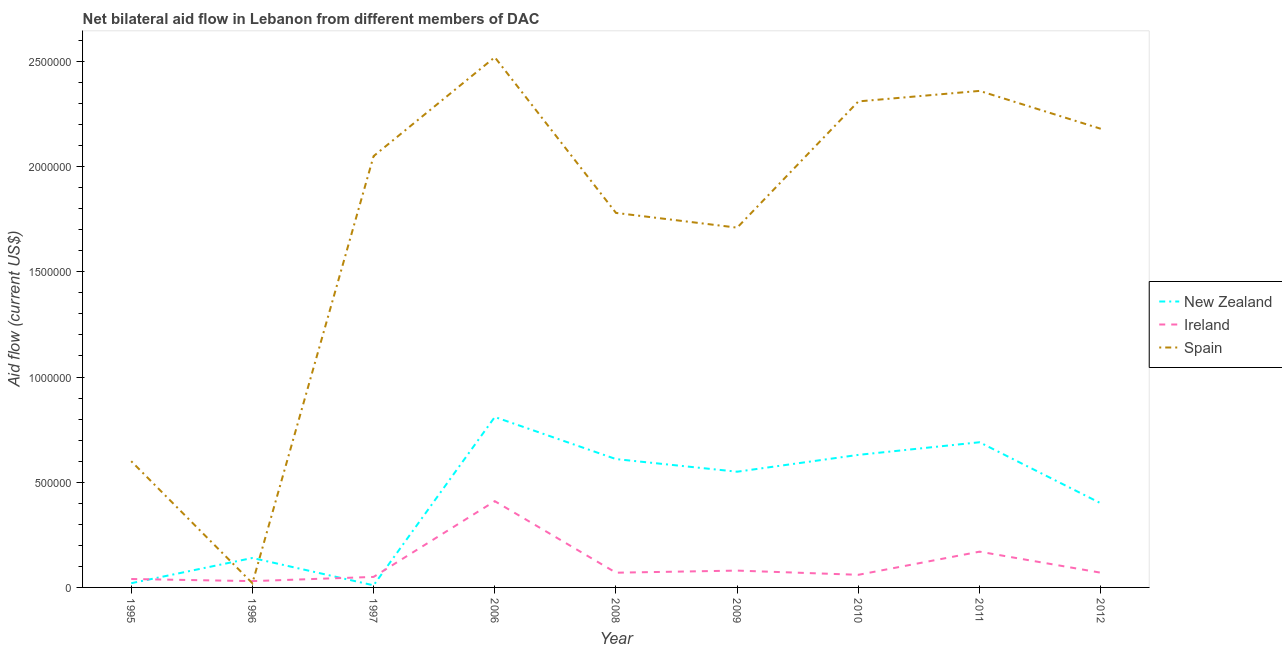Is the number of lines equal to the number of legend labels?
Give a very brief answer. Yes. What is the amount of aid provided by ireland in 2012?
Ensure brevity in your answer.  7.00e+04. Across all years, what is the maximum amount of aid provided by new zealand?
Give a very brief answer. 8.10e+05. Across all years, what is the minimum amount of aid provided by ireland?
Ensure brevity in your answer.  3.00e+04. In which year was the amount of aid provided by ireland maximum?
Ensure brevity in your answer.  2006. What is the total amount of aid provided by new zealand in the graph?
Provide a succinct answer. 3.86e+06. What is the difference between the amount of aid provided by new zealand in 1996 and that in 2010?
Provide a short and direct response. -4.90e+05. What is the difference between the amount of aid provided by ireland in 2006 and the amount of aid provided by spain in 1996?
Give a very brief answer. 3.90e+05. What is the average amount of aid provided by spain per year?
Offer a terse response. 1.73e+06. In the year 1996, what is the difference between the amount of aid provided by new zealand and amount of aid provided by spain?
Your response must be concise. 1.20e+05. What is the ratio of the amount of aid provided by ireland in 1997 to that in 2010?
Offer a very short reply. 0.83. What is the difference between the highest and the second highest amount of aid provided by ireland?
Provide a short and direct response. 2.40e+05. What is the difference between the highest and the lowest amount of aid provided by ireland?
Provide a succinct answer. 3.80e+05. In how many years, is the amount of aid provided by spain greater than the average amount of aid provided by spain taken over all years?
Provide a succinct answer. 6. Is the sum of the amount of aid provided by ireland in 1997 and 2009 greater than the maximum amount of aid provided by new zealand across all years?
Your answer should be very brief. No. Is it the case that in every year, the sum of the amount of aid provided by new zealand and amount of aid provided by ireland is greater than the amount of aid provided by spain?
Give a very brief answer. No. Is the amount of aid provided by spain strictly less than the amount of aid provided by new zealand over the years?
Offer a terse response. No. How many lines are there?
Make the answer very short. 3. What is the difference between two consecutive major ticks on the Y-axis?
Your answer should be compact. 5.00e+05. Does the graph contain any zero values?
Ensure brevity in your answer.  No. Does the graph contain grids?
Offer a very short reply. No. How many legend labels are there?
Give a very brief answer. 3. How are the legend labels stacked?
Provide a succinct answer. Vertical. What is the title of the graph?
Provide a succinct answer. Net bilateral aid flow in Lebanon from different members of DAC. Does "Unpaid family workers" appear as one of the legend labels in the graph?
Provide a succinct answer. No. What is the label or title of the X-axis?
Your answer should be very brief. Year. What is the Aid flow (current US$) of New Zealand in 1995?
Provide a short and direct response. 2.00e+04. What is the Aid flow (current US$) in Ireland in 1995?
Offer a terse response. 4.00e+04. What is the Aid flow (current US$) in New Zealand in 1996?
Provide a succinct answer. 1.40e+05. What is the Aid flow (current US$) of Spain in 1996?
Give a very brief answer. 2.00e+04. What is the Aid flow (current US$) in Ireland in 1997?
Keep it short and to the point. 5.00e+04. What is the Aid flow (current US$) of Spain in 1997?
Offer a very short reply. 2.05e+06. What is the Aid flow (current US$) in New Zealand in 2006?
Offer a very short reply. 8.10e+05. What is the Aid flow (current US$) in Spain in 2006?
Provide a succinct answer. 2.52e+06. What is the Aid flow (current US$) in New Zealand in 2008?
Offer a very short reply. 6.10e+05. What is the Aid flow (current US$) of Spain in 2008?
Make the answer very short. 1.78e+06. What is the Aid flow (current US$) in New Zealand in 2009?
Ensure brevity in your answer.  5.50e+05. What is the Aid flow (current US$) in Ireland in 2009?
Ensure brevity in your answer.  8.00e+04. What is the Aid flow (current US$) in Spain in 2009?
Your response must be concise. 1.71e+06. What is the Aid flow (current US$) in New Zealand in 2010?
Keep it short and to the point. 6.30e+05. What is the Aid flow (current US$) of Ireland in 2010?
Your answer should be compact. 6.00e+04. What is the Aid flow (current US$) of Spain in 2010?
Offer a very short reply. 2.31e+06. What is the Aid flow (current US$) of New Zealand in 2011?
Your answer should be very brief. 6.90e+05. What is the Aid flow (current US$) in Spain in 2011?
Ensure brevity in your answer.  2.36e+06. What is the Aid flow (current US$) in New Zealand in 2012?
Ensure brevity in your answer.  4.00e+05. What is the Aid flow (current US$) in Spain in 2012?
Your response must be concise. 2.18e+06. Across all years, what is the maximum Aid flow (current US$) in New Zealand?
Give a very brief answer. 8.10e+05. Across all years, what is the maximum Aid flow (current US$) in Spain?
Offer a terse response. 2.52e+06. Across all years, what is the minimum Aid flow (current US$) of Ireland?
Keep it short and to the point. 3.00e+04. Across all years, what is the minimum Aid flow (current US$) in Spain?
Provide a succinct answer. 2.00e+04. What is the total Aid flow (current US$) in New Zealand in the graph?
Your answer should be compact. 3.86e+06. What is the total Aid flow (current US$) in Ireland in the graph?
Offer a very short reply. 9.80e+05. What is the total Aid flow (current US$) in Spain in the graph?
Offer a very short reply. 1.55e+07. What is the difference between the Aid flow (current US$) in Ireland in 1995 and that in 1996?
Make the answer very short. 10000. What is the difference between the Aid flow (current US$) in Spain in 1995 and that in 1996?
Your answer should be compact. 5.80e+05. What is the difference between the Aid flow (current US$) of Spain in 1995 and that in 1997?
Your answer should be compact. -1.45e+06. What is the difference between the Aid flow (current US$) in New Zealand in 1995 and that in 2006?
Provide a succinct answer. -7.90e+05. What is the difference between the Aid flow (current US$) in Ireland in 1995 and that in 2006?
Give a very brief answer. -3.70e+05. What is the difference between the Aid flow (current US$) of Spain in 1995 and that in 2006?
Provide a short and direct response. -1.92e+06. What is the difference between the Aid flow (current US$) in New Zealand in 1995 and that in 2008?
Keep it short and to the point. -5.90e+05. What is the difference between the Aid flow (current US$) in Spain in 1995 and that in 2008?
Give a very brief answer. -1.18e+06. What is the difference between the Aid flow (current US$) in New Zealand in 1995 and that in 2009?
Offer a terse response. -5.30e+05. What is the difference between the Aid flow (current US$) in Spain in 1995 and that in 2009?
Your response must be concise. -1.11e+06. What is the difference between the Aid flow (current US$) in New Zealand in 1995 and that in 2010?
Offer a terse response. -6.10e+05. What is the difference between the Aid flow (current US$) in Spain in 1995 and that in 2010?
Provide a short and direct response. -1.71e+06. What is the difference between the Aid flow (current US$) of New Zealand in 1995 and that in 2011?
Your answer should be very brief. -6.70e+05. What is the difference between the Aid flow (current US$) in Spain in 1995 and that in 2011?
Keep it short and to the point. -1.76e+06. What is the difference between the Aid flow (current US$) in New Zealand in 1995 and that in 2012?
Make the answer very short. -3.80e+05. What is the difference between the Aid flow (current US$) in Spain in 1995 and that in 2012?
Offer a terse response. -1.58e+06. What is the difference between the Aid flow (current US$) in New Zealand in 1996 and that in 1997?
Your answer should be compact. 1.30e+05. What is the difference between the Aid flow (current US$) in Spain in 1996 and that in 1997?
Offer a terse response. -2.03e+06. What is the difference between the Aid flow (current US$) in New Zealand in 1996 and that in 2006?
Your answer should be compact. -6.70e+05. What is the difference between the Aid flow (current US$) of Ireland in 1996 and that in 2006?
Your answer should be compact. -3.80e+05. What is the difference between the Aid flow (current US$) of Spain in 1996 and that in 2006?
Your response must be concise. -2.50e+06. What is the difference between the Aid flow (current US$) in New Zealand in 1996 and that in 2008?
Ensure brevity in your answer.  -4.70e+05. What is the difference between the Aid flow (current US$) in Ireland in 1996 and that in 2008?
Provide a succinct answer. -4.00e+04. What is the difference between the Aid flow (current US$) in Spain in 1996 and that in 2008?
Offer a terse response. -1.76e+06. What is the difference between the Aid flow (current US$) in New Zealand in 1996 and that in 2009?
Your response must be concise. -4.10e+05. What is the difference between the Aid flow (current US$) in Ireland in 1996 and that in 2009?
Make the answer very short. -5.00e+04. What is the difference between the Aid flow (current US$) in Spain in 1996 and that in 2009?
Make the answer very short. -1.69e+06. What is the difference between the Aid flow (current US$) of New Zealand in 1996 and that in 2010?
Ensure brevity in your answer.  -4.90e+05. What is the difference between the Aid flow (current US$) of Spain in 1996 and that in 2010?
Provide a short and direct response. -2.29e+06. What is the difference between the Aid flow (current US$) in New Zealand in 1996 and that in 2011?
Your answer should be very brief. -5.50e+05. What is the difference between the Aid flow (current US$) in Spain in 1996 and that in 2011?
Provide a succinct answer. -2.34e+06. What is the difference between the Aid flow (current US$) of Ireland in 1996 and that in 2012?
Provide a succinct answer. -4.00e+04. What is the difference between the Aid flow (current US$) of Spain in 1996 and that in 2012?
Ensure brevity in your answer.  -2.16e+06. What is the difference between the Aid flow (current US$) of New Zealand in 1997 and that in 2006?
Your answer should be compact. -8.00e+05. What is the difference between the Aid flow (current US$) of Ireland in 1997 and that in 2006?
Give a very brief answer. -3.60e+05. What is the difference between the Aid flow (current US$) in Spain in 1997 and that in 2006?
Make the answer very short. -4.70e+05. What is the difference between the Aid flow (current US$) in New Zealand in 1997 and that in 2008?
Ensure brevity in your answer.  -6.00e+05. What is the difference between the Aid flow (current US$) of Spain in 1997 and that in 2008?
Make the answer very short. 2.70e+05. What is the difference between the Aid flow (current US$) of New Zealand in 1997 and that in 2009?
Ensure brevity in your answer.  -5.40e+05. What is the difference between the Aid flow (current US$) in New Zealand in 1997 and that in 2010?
Ensure brevity in your answer.  -6.20e+05. What is the difference between the Aid flow (current US$) in Ireland in 1997 and that in 2010?
Keep it short and to the point. -10000. What is the difference between the Aid flow (current US$) of Spain in 1997 and that in 2010?
Your response must be concise. -2.60e+05. What is the difference between the Aid flow (current US$) of New Zealand in 1997 and that in 2011?
Your response must be concise. -6.80e+05. What is the difference between the Aid flow (current US$) in Ireland in 1997 and that in 2011?
Provide a succinct answer. -1.20e+05. What is the difference between the Aid flow (current US$) of Spain in 1997 and that in 2011?
Ensure brevity in your answer.  -3.10e+05. What is the difference between the Aid flow (current US$) of New Zealand in 1997 and that in 2012?
Your answer should be compact. -3.90e+05. What is the difference between the Aid flow (current US$) in Ireland in 1997 and that in 2012?
Ensure brevity in your answer.  -2.00e+04. What is the difference between the Aid flow (current US$) of Spain in 1997 and that in 2012?
Offer a terse response. -1.30e+05. What is the difference between the Aid flow (current US$) of Spain in 2006 and that in 2008?
Offer a terse response. 7.40e+05. What is the difference between the Aid flow (current US$) in Spain in 2006 and that in 2009?
Make the answer very short. 8.10e+05. What is the difference between the Aid flow (current US$) in Spain in 2006 and that in 2010?
Offer a terse response. 2.10e+05. What is the difference between the Aid flow (current US$) in Ireland in 2006 and that in 2011?
Offer a very short reply. 2.40e+05. What is the difference between the Aid flow (current US$) of Spain in 2006 and that in 2011?
Offer a terse response. 1.60e+05. What is the difference between the Aid flow (current US$) in New Zealand in 2006 and that in 2012?
Make the answer very short. 4.10e+05. What is the difference between the Aid flow (current US$) of New Zealand in 2008 and that in 2009?
Make the answer very short. 6.00e+04. What is the difference between the Aid flow (current US$) of Ireland in 2008 and that in 2009?
Your answer should be very brief. -10000. What is the difference between the Aid flow (current US$) in Spain in 2008 and that in 2009?
Give a very brief answer. 7.00e+04. What is the difference between the Aid flow (current US$) in New Zealand in 2008 and that in 2010?
Give a very brief answer. -2.00e+04. What is the difference between the Aid flow (current US$) in Ireland in 2008 and that in 2010?
Provide a succinct answer. 10000. What is the difference between the Aid flow (current US$) in Spain in 2008 and that in 2010?
Give a very brief answer. -5.30e+05. What is the difference between the Aid flow (current US$) in New Zealand in 2008 and that in 2011?
Your response must be concise. -8.00e+04. What is the difference between the Aid flow (current US$) of Ireland in 2008 and that in 2011?
Provide a short and direct response. -1.00e+05. What is the difference between the Aid flow (current US$) in Spain in 2008 and that in 2011?
Give a very brief answer. -5.80e+05. What is the difference between the Aid flow (current US$) of Spain in 2008 and that in 2012?
Your answer should be compact. -4.00e+05. What is the difference between the Aid flow (current US$) in Spain in 2009 and that in 2010?
Your response must be concise. -6.00e+05. What is the difference between the Aid flow (current US$) of Ireland in 2009 and that in 2011?
Your answer should be very brief. -9.00e+04. What is the difference between the Aid flow (current US$) of Spain in 2009 and that in 2011?
Provide a short and direct response. -6.50e+05. What is the difference between the Aid flow (current US$) of New Zealand in 2009 and that in 2012?
Offer a very short reply. 1.50e+05. What is the difference between the Aid flow (current US$) of Spain in 2009 and that in 2012?
Provide a short and direct response. -4.70e+05. What is the difference between the Aid flow (current US$) of New Zealand in 2010 and that in 2011?
Your response must be concise. -6.00e+04. What is the difference between the Aid flow (current US$) of Ireland in 2010 and that in 2011?
Offer a terse response. -1.10e+05. What is the difference between the Aid flow (current US$) of New Zealand in 2010 and that in 2012?
Ensure brevity in your answer.  2.30e+05. What is the difference between the Aid flow (current US$) in Ireland in 2010 and that in 2012?
Give a very brief answer. -10000. What is the difference between the Aid flow (current US$) of Spain in 2010 and that in 2012?
Offer a very short reply. 1.30e+05. What is the difference between the Aid flow (current US$) of New Zealand in 2011 and that in 2012?
Offer a very short reply. 2.90e+05. What is the difference between the Aid flow (current US$) in Spain in 2011 and that in 2012?
Provide a short and direct response. 1.80e+05. What is the difference between the Aid flow (current US$) of New Zealand in 1995 and the Aid flow (current US$) of Ireland in 1996?
Provide a succinct answer. -10000. What is the difference between the Aid flow (current US$) in New Zealand in 1995 and the Aid flow (current US$) in Spain in 1996?
Your response must be concise. 0. What is the difference between the Aid flow (current US$) in Ireland in 1995 and the Aid flow (current US$) in Spain in 1996?
Give a very brief answer. 2.00e+04. What is the difference between the Aid flow (current US$) in New Zealand in 1995 and the Aid flow (current US$) in Spain in 1997?
Ensure brevity in your answer.  -2.03e+06. What is the difference between the Aid flow (current US$) of Ireland in 1995 and the Aid flow (current US$) of Spain in 1997?
Your answer should be very brief. -2.01e+06. What is the difference between the Aid flow (current US$) of New Zealand in 1995 and the Aid flow (current US$) of Ireland in 2006?
Make the answer very short. -3.90e+05. What is the difference between the Aid flow (current US$) of New Zealand in 1995 and the Aid flow (current US$) of Spain in 2006?
Make the answer very short. -2.50e+06. What is the difference between the Aid flow (current US$) in Ireland in 1995 and the Aid flow (current US$) in Spain in 2006?
Keep it short and to the point. -2.48e+06. What is the difference between the Aid flow (current US$) in New Zealand in 1995 and the Aid flow (current US$) in Spain in 2008?
Your response must be concise. -1.76e+06. What is the difference between the Aid flow (current US$) in Ireland in 1995 and the Aid flow (current US$) in Spain in 2008?
Give a very brief answer. -1.74e+06. What is the difference between the Aid flow (current US$) of New Zealand in 1995 and the Aid flow (current US$) of Spain in 2009?
Offer a very short reply. -1.69e+06. What is the difference between the Aid flow (current US$) in Ireland in 1995 and the Aid flow (current US$) in Spain in 2009?
Provide a succinct answer. -1.67e+06. What is the difference between the Aid flow (current US$) of New Zealand in 1995 and the Aid flow (current US$) of Ireland in 2010?
Your answer should be very brief. -4.00e+04. What is the difference between the Aid flow (current US$) of New Zealand in 1995 and the Aid flow (current US$) of Spain in 2010?
Keep it short and to the point. -2.29e+06. What is the difference between the Aid flow (current US$) in Ireland in 1995 and the Aid flow (current US$) in Spain in 2010?
Keep it short and to the point. -2.27e+06. What is the difference between the Aid flow (current US$) of New Zealand in 1995 and the Aid flow (current US$) of Ireland in 2011?
Offer a very short reply. -1.50e+05. What is the difference between the Aid flow (current US$) in New Zealand in 1995 and the Aid flow (current US$) in Spain in 2011?
Give a very brief answer. -2.34e+06. What is the difference between the Aid flow (current US$) of Ireland in 1995 and the Aid flow (current US$) of Spain in 2011?
Give a very brief answer. -2.32e+06. What is the difference between the Aid flow (current US$) of New Zealand in 1995 and the Aid flow (current US$) of Spain in 2012?
Ensure brevity in your answer.  -2.16e+06. What is the difference between the Aid flow (current US$) in Ireland in 1995 and the Aid flow (current US$) in Spain in 2012?
Your answer should be compact. -2.14e+06. What is the difference between the Aid flow (current US$) of New Zealand in 1996 and the Aid flow (current US$) of Ireland in 1997?
Keep it short and to the point. 9.00e+04. What is the difference between the Aid flow (current US$) in New Zealand in 1996 and the Aid flow (current US$) in Spain in 1997?
Provide a succinct answer. -1.91e+06. What is the difference between the Aid flow (current US$) of Ireland in 1996 and the Aid flow (current US$) of Spain in 1997?
Your answer should be very brief. -2.02e+06. What is the difference between the Aid flow (current US$) in New Zealand in 1996 and the Aid flow (current US$) in Spain in 2006?
Your response must be concise. -2.38e+06. What is the difference between the Aid flow (current US$) in Ireland in 1996 and the Aid flow (current US$) in Spain in 2006?
Your answer should be very brief. -2.49e+06. What is the difference between the Aid flow (current US$) of New Zealand in 1996 and the Aid flow (current US$) of Ireland in 2008?
Give a very brief answer. 7.00e+04. What is the difference between the Aid flow (current US$) of New Zealand in 1996 and the Aid flow (current US$) of Spain in 2008?
Give a very brief answer. -1.64e+06. What is the difference between the Aid flow (current US$) in Ireland in 1996 and the Aid flow (current US$) in Spain in 2008?
Give a very brief answer. -1.75e+06. What is the difference between the Aid flow (current US$) in New Zealand in 1996 and the Aid flow (current US$) in Spain in 2009?
Make the answer very short. -1.57e+06. What is the difference between the Aid flow (current US$) of Ireland in 1996 and the Aid flow (current US$) of Spain in 2009?
Your answer should be very brief. -1.68e+06. What is the difference between the Aid flow (current US$) in New Zealand in 1996 and the Aid flow (current US$) in Ireland in 2010?
Offer a terse response. 8.00e+04. What is the difference between the Aid flow (current US$) in New Zealand in 1996 and the Aid flow (current US$) in Spain in 2010?
Give a very brief answer. -2.17e+06. What is the difference between the Aid flow (current US$) of Ireland in 1996 and the Aid flow (current US$) of Spain in 2010?
Your response must be concise. -2.28e+06. What is the difference between the Aid flow (current US$) of New Zealand in 1996 and the Aid flow (current US$) of Spain in 2011?
Your answer should be very brief. -2.22e+06. What is the difference between the Aid flow (current US$) in Ireland in 1996 and the Aid flow (current US$) in Spain in 2011?
Provide a short and direct response. -2.33e+06. What is the difference between the Aid flow (current US$) in New Zealand in 1996 and the Aid flow (current US$) in Ireland in 2012?
Your answer should be very brief. 7.00e+04. What is the difference between the Aid flow (current US$) in New Zealand in 1996 and the Aid flow (current US$) in Spain in 2012?
Offer a very short reply. -2.04e+06. What is the difference between the Aid flow (current US$) of Ireland in 1996 and the Aid flow (current US$) of Spain in 2012?
Give a very brief answer. -2.15e+06. What is the difference between the Aid flow (current US$) in New Zealand in 1997 and the Aid flow (current US$) in Ireland in 2006?
Provide a short and direct response. -4.00e+05. What is the difference between the Aid flow (current US$) of New Zealand in 1997 and the Aid flow (current US$) of Spain in 2006?
Ensure brevity in your answer.  -2.51e+06. What is the difference between the Aid flow (current US$) in Ireland in 1997 and the Aid flow (current US$) in Spain in 2006?
Your answer should be very brief. -2.47e+06. What is the difference between the Aid flow (current US$) in New Zealand in 1997 and the Aid flow (current US$) in Spain in 2008?
Your response must be concise. -1.77e+06. What is the difference between the Aid flow (current US$) in Ireland in 1997 and the Aid flow (current US$) in Spain in 2008?
Provide a short and direct response. -1.73e+06. What is the difference between the Aid flow (current US$) of New Zealand in 1997 and the Aid flow (current US$) of Spain in 2009?
Your response must be concise. -1.70e+06. What is the difference between the Aid flow (current US$) in Ireland in 1997 and the Aid flow (current US$) in Spain in 2009?
Offer a very short reply. -1.66e+06. What is the difference between the Aid flow (current US$) of New Zealand in 1997 and the Aid flow (current US$) of Spain in 2010?
Your response must be concise. -2.30e+06. What is the difference between the Aid flow (current US$) in Ireland in 1997 and the Aid flow (current US$) in Spain in 2010?
Your answer should be compact. -2.26e+06. What is the difference between the Aid flow (current US$) in New Zealand in 1997 and the Aid flow (current US$) in Spain in 2011?
Offer a very short reply. -2.35e+06. What is the difference between the Aid flow (current US$) in Ireland in 1997 and the Aid flow (current US$) in Spain in 2011?
Keep it short and to the point. -2.31e+06. What is the difference between the Aid flow (current US$) of New Zealand in 1997 and the Aid flow (current US$) of Ireland in 2012?
Give a very brief answer. -6.00e+04. What is the difference between the Aid flow (current US$) in New Zealand in 1997 and the Aid flow (current US$) in Spain in 2012?
Keep it short and to the point. -2.17e+06. What is the difference between the Aid flow (current US$) in Ireland in 1997 and the Aid flow (current US$) in Spain in 2012?
Your answer should be very brief. -2.13e+06. What is the difference between the Aid flow (current US$) of New Zealand in 2006 and the Aid flow (current US$) of Ireland in 2008?
Make the answer very short. 7.40e+05. What is the difference between the Aid flow (current US$) of New Zealand in 2006 and the Aid flow (current US$) of Spain in 2008?
Make the answer very short. -9.70e+05. What is the difference between the Aid flow (current US$) in Ireland in 2006 and the Aid flow (current US$) in Spain in 2008?
Give a very brief answer. -1.37e+06. What is the difference between the Aid flow (current US$) of New Zealand in 2006 and the Aid flow (current US$) of Ireland in 2009?
Keep it short and to the point. 7.30e+05. What is the difference between the Aid flow (current US$) of New Zealand in 2006 and the Aid flow (current US$) of Spain in 2009?
Offer a terse response. -9.00e+05. What is the difference between the Aid flow (current US$) of Ireland in 2006 and the Aid flow (current US$) of Spain in 2009?
Keep it short and to the point. -1.30e+06. What is the difference between the Aid flow (current US$) of New Zealand in 2006 and the Aid flow (current US$) of Ireland in 2010?
Give a very brief answer. 7.50e+05. What is the difference between the Aid flow (current US$) in New Zealand in 2006 and the Aid flow (current US$) in Spain in 2010?
Ensure brevity in your answer.  -1.50e+06. What is the difference between the Aid flow (current US$) of Ireland in 2006 and the Aid flow (current US$) of Spain in 2010?
Provide a succinct answer. -1.90e+06. What is the difference between the Aid flow (current US$) in New Zealand in 2006 and the Aid flow (current US$) in Ireland in 2011?
Your answer should be very brief. 6.40e+05. What is the difference between the Aid flow (current US$) in New Zealand in 2006 and the Aid flow (current US$) in Spain in 2011?
Your answer should be very brief. -1.55e+06. What is the difference between the Aid flow (current US$) in Ireland in 2006 and the Aid flow (current US$) in Spain in 2011?
Provide a short and direct response. -1.95e+06. What is the difference between the Aid flow (current US$) in New Zealand in 2006 and the Aid flow (current US$) in Ireland in 2012?
Make the answer very short. 7.40e+05. What is the difference between the Aid flow (current US$) of New Zealand in 2006 and the Aid flow (current US$) of Spain in 2012?
Offer a terse response. -1.37e+06. What is the difference between the Aid flow (current US$) in Ireland in 2006 and the Aid flow (current US$) in Spain in 2012?
Your answer should be compact. -1.77e+06. What is the difference between the Aid flow (current US$) in New Zealand in 2008 and the Aid flow (current US$) in Ireland in 2009?
Ensure brevity in your answer.  5.30e+05. What is the difference between the Aid flow (current US$) of New Zealand in 2008 and the Aid flow (current US$) of Spain in 2009?
Provide a short and direct response. -1.10e+06. What is the difference between the Aid flow (current US$) of Ireland in 2008 and the Aid flow (current US$) of Spain in 2009?
Your response must be concise. -1.64e+06. What is the difference between the Aid flow (current US$) of New Zealand in 2008 and the Aid flow (current US$) of Ireland in 2010?
Offer a very short reply. 5.50e+05. What is the difference between the Aid flow (current US$) in New Zealand in 2008 and the Aid flow (current US$) in Spain in 2010?
Your response must be concise. -1.70e+06. What is the difference between the Aid flow (current US$) of Ireland in 2008 and the Aid flow (current US$) of Spain in 2010?
Keep it short and to the point. -2.24e+06. What is the difference between the Aid flow (current US$) in New Zealand in 2008 and the Aid flow (current US$) in Spain in 2011?
Keep it short and to the point. -1.75e+06. What is the difference between the Aid flow (current US$) of Ireland in 2008 and the Aid flow (current US$) of Spain in 2011?
Provide a succinct answer. -2.29e+06. What is the difference between the Aid flow (current US$) in New Zealand in 2008 and the Aid flow (current US$) in Ireland in 2012?
Keep it short and to the point. 5.40e+05. What is the difference between the Aid flow (current US$) in New Zealand in 2008 and the Aid flow (current US$) in Spain in 2012?
Provide a succinct answer. -1.57e+06. What is the difference between the Aid flow (current US$) in Ireland in 2008 and the Aid flow (current US$) in Spain in 2012?
Ensure brevity in your answer.  -2.11e+06. What is the difference between the Aid flow (current US$) of New Zealand in 2009 and the Aid flow (current US$) of Ireland in 2010?
Ensure brevity in your answer.  4.90e+05. What is the difference between the Aid flow (current US$) in New Zealand in 2009 and the Aid flow (current US$) in Spain in 2010?
Give a very brief answer. -1.76e+06. What is the difference between the Aid flow (current US$) in Ireland in 2009 and the Aid flow (current US$) in Spain in 2010?
Your answer should be very brief. -2.23e+06. What is the difference between the Aid flow (current US$) in New Zealand in 2009 and the Aid flow (current US$) in Ireland in 2011?
Ensure brevity in your answer.  3.80e+05. What is the difference between the Aid flow (current US$) in New Zealand in 2009 and the Aid flow (current US$) in Spain in 2011?
Your answer should be very brief. -1.81e+06. What is the difference between the Aid flow (current US$) in Ireland in 2009 and the Aid flow (current US$) in Spain in 2011?
Provide a short and direct response. -2.28e+06. What is the difference between the Aid flow (current US$) in New Zealand in 2009 and the Aid flow (current US$) in Ireland in 2012?
Your answer should be compact. 4.80e+05. What is the difference between the Aid flow (current US$) of New Zealand in 2009 and the Aid flow (current US$) of Spain in 2012?
Offer a terse response. -1.63e+06. What is the difference between the Aid flow (current US$) in Ireland in 2009 and the Aid flow (current US$) in Spain in 2012?
Offer a very short reply. -2.10e+06. What is the difference between the Aid flow (current US$) of New Zealand in 2010 and the Aid flow (current US$) of Ireland in 2011?
Offer a very short reply. 4.60e+05. What is the difference between the Aid flow (current US$) in New Zealand in 2010 and the Aid flow (current US$) in Spain in 2011?
Provide a succinct answer. -1.73e+06. What is the difference between the Aid flow (current US$) of Ireland in 2010 and the Aid flow (current US$) of Spain in 2011?
Ensure brevity in your answer.  -2.30e+06. What is the difference between the Aid flow (current US$) in New Zealand in 2010 and the Aid flow (current US$) in Ireland in 2012?
Offer a very short reply. 5.60e+05. What is the difference between the Aid flow (current US$) in New Zealand in 2010 and the Aid flow (current US$) in Spain in 2012?
Your answer should be compact. -1.55e+06. What is the difference between the Aid flow (current US$) of Ireland in 2010 and the Aid flow (current US$) of Spain in 2012?
Your answer should be compact. -2.12e+06. What is the difference between the Aid flow (current US$) of New Zealand in 2011 and the Aid flow (current US$) of Ireland in 2012?
Your response must be concise. 6.20e+05. What is the difference between the Aid flow (current US$) in New Zealand in 2011 and the Aid flow (current US$) in Spain in 2012?
Give a very brief answer. -1.49e+06. What is the difference between the Aid flow (current US$) in Ireland in 2011 and the Aid flow (current US$) in Spain in 2012?
Give a very brief answer. -2.01e+06. What is the average Aid flow (current US$) of New Zealand per year?
Ensure brevity in your answer.  4.29e+05. What is the average Aid flow (current US$) in Ireland per year?
Offer a very short reply. 1.09e+05. What is the average Aid flow (current US$) of Spain per year?
Your answer should be very brief. 1.73e+06. In the year 1995, what is the difference between the Aid flow (current US$) in New Zealand and Aid flow (current US$) in Spain?
Your answer should be compact. -5.80e+05. In the year 1995, what is the difference between the Aid flow (current US$) in Ireland and Aid flow (current US$) in Spain?
Provide a succinct answer. -5.60e+05. In the year 1997, what is the difference between the Aid flow (current US$) of New Zealand and Aid flow (current US$) of Spain?
Your response must be concise. -2.04e+06. In the year 1997, what is the difference between the Aid flow (current US$) of Ireland and Aid flow (current US$) of Spain?
Give a very brief answer. -2.00e+06. In the year 2006, what is the difference between the Aid flow (current US$) in New Zealand and Aid flow (current US$) in Spain?
Offer a very short reply. -1.71e+06. In the year 2006, what is the difference between the Aid flow (current US$) of Ireland and Aid flow (current US$) of Spain?
Offer a terse response. -2.11e+06. In the year 2008, what is the difference between the Aid flow (current US$) of New Zealand and Aid flow (current US$) of Ireland?
Give a very brief answer. 5.40e+05. In the year 2008, what is the difference between the Aid flow (current US$) in New Zealand and Aid flow (current US$) in Spain?
Provide a short and direct response. -1.17e+06. In the year 2008, what is the difference between the Aid flow (current US$) in Ireland and Aid flow (current US$) in Spain?
Your answer should be very brief. -1.71e+06. In the year 2009, what is the difference between the Aid flow (current US$) in New Zealand and Aid flow (current US$) in Spain?
Ensure brevity in your answer.  -1.16e+06. In the year 2009, what is the difference between the Aid flow (current US$) in Ireland and Aid flow (current US$) in Spain?
Offer a terse response. -1.63e+06. In the year 2010, what is the difference between the Aid flow (current US$) of New Zealand and Aid flow (current US$) of Ireland?
Make the answer very short. 5.70e+05. In the year 2010, what is the difference between the Aid flow (current US$) of New Zealand and Aid flow (current US$) of Spain?
Offer a terse response. -1.68e+06. In the year 2010, what is the difference between the Aid flow (current US$) of Ireland and Aid flow (current US$) of Spain?
Your answer should be very brief. -2.25e+06. In the year 2011, what is the difference between the Aid flow (current US$) in New Zealand and Aid flow (current US$) in Ireland?
Your answer should be compact. 5.20e+05. In the year 2011, what is the difference between the Aid flow (current US$) in New Zealand and Aid flow (current US$) in Spain?
Your response must be concise. -1.67e+06. In the year 2011, what is the difference between the Aid flow (current US$) of Ireland and Aid flow (current US$) of Spain?
Your answer should be very brief. -2.19e+06. In the year 2012, what is the difference between the Aid flow (current US$) in New Zealand and Aid flow (current US$) in Spain?
Your response must be concise. -1.78e+06. In the year 2012, what is the difference between the Aid flow (current US$) of Ireland and Aid flow (current US$) of Spain?
Your answer should be very brief. -2.11e+06. What is the ratio of the Aid flow (current US$) in New Zealand in 1995 to that in 1996?
Your answer should be compact. 0.14. What is the ratio of the Aid flow (current US$) in New Zealand in 1995 to that in 1997?
Offer a terse response. 2. What is the ratio of the Aid flow (current US$) in Spain in 1995 to that in 1997?
Your answer should be very brief. 0.29. What is the ratio of the Aid flow (current US$) in New Zealand in 1995 to that in 2006?
Make the answer very short. 0.02. What is the ratio of the Aid flow (current US$) in Ireland in 1995 to that in 2006?
Provide a short and direct response. 0.1. What is the ratio of the Aid flow (current US$) of Spain in 1995 to that in 2006?
Give a very brief answer. 0.24. What is the ratio of the Aid flow (current US$) of New Zealand in 1995 to that in 2008?
Provide a short and direct response. 0.03. What is the ratio of the Aid flow (current US$) of Spain in 1995 to that in 2008?
Your answer should be very brief. 0.34. What is the ratio of the Aid flow (current US$) of New Zealand in 1995 to that in 2009?
Your answer should be very brief. 0.04. What is the ratio of the Aid flow (current US$) in Ireland in 1995 to that in 2009?
Provide a short and direct response. 0.5. What is the ratio of the Aid flow (current US$) of Spain in 1995 to that in 2009?
Provide a succinct answer. 0.35. What is the ratio of the Aid flow (current US$) of New Zealand in 1995 to that in 2010?
Offer a very short reply. 0.03. What is the ratio of the Aid flow (current US$) in Spain in 1995 to that in 2010?
Your response must be concise. 0.26. What is the ratio of the Aid flow (current US$) in New Zealand in 1995 to that in 2011?
Your answer should be compact. 0.03. What is the ratio of the Aid flow (current US$) of Ireland in 1995 to that in 2011?
Offer a very short reply. 0.24. What is the ratio of the Aid flow (current US$) of Spain in 1995 to that in 2011?
Provide a succinct answer. 0.25. What is the ratio of the Aid flow (current US$) of New Zealand in 1995 to that in 2012?
Your answer should be very brief. 0.05. What is the ratio of the Aid flow (current US$) of Spain in 1995 to that in 2012?
Your response must be concise. 0.28. What is the ratio of the Aid flow (current US$) in Spain in 1996 to that in 1997?
Provide a succinct answer. 0.01. What is the ratio of the Aid flow (current US$) of New Zealand in 1996 to that in 2006?
Ensure brevity in your answer.  0.17. What is the ratio of the Aid flow (current US$) in Ireland in 1996 to that in 2006?
Make the answer very short. 0.07. What is the ratio of the Aid flow (current US$) in Spain in 1996 to that in 2006?
Your response must be concise. 0.01. What is the ratio of the Aid flow (current US$) of New Zealand in 1996 to that in 2008?
Ensure brevity in your answer.  0.23. What is the ratio of the Aid flow (current US$) in Ireland in 1996 to that in 2008?
Your answer should be compact. 0.43. What is the ratio of the Aid flow (current US$) of Spain in 1996 to that in 2008?
Provide a succinct answer. 0.01. What is the ratio of the Aid flow (current US$) in New Zealand in 1996 to that in 2009?
Give a very brief answer. 0.25. What is the ratio of the Aid flow (current US$) in Ireland in 1996 to that in 2009?
Make the answer very short. 0.38. What is the ratio of the Aid flow (current US$) in Spain in 1996 to that in 2009?
Keep it short and to the point. 0.01. What is the ratio of the Aid flow (current US$) in New Zealand in 1996 to that in 2010?
Provide a succinct answer. 0.22. What is the ratio of the Aid flow (current US$) of Ireland in 1996 to that in 2010?
Provide a short and direct response. 0.5. What is the ratio of the Aid flow (current US$) in Spain in 1996 to that in 2010?
Ensure brevity in your answer.  0.01. What is the ratio of the Aid flow (current US$) of New Zealand in 1996 to that in 2011?
Provide a succinct answer. 0.2. What is the ratio of the Aid flow (current US$) of Ireland in 1996 to that in 2011?
Offer a terse response. 0.18. What is the ratio of the Aid flow (current US$) of Spain in 1996 to that in 2011?
Your answer should be very brief. 0.01. What is the ratio of the Aid flow (current US$) in New Zealand in 1996 to that in 2012?
Your answer should be compact. 0.35. What is the ratio of the Aid flow (current US$) of Ireland in 1996 to that in 2012?
Provide a short and direct response. 0.43. What is the ratio of the Aid flow (current US$) in Spain in 1996 to that in 2012?
Your answer should be compact. 0.01. What is the ratio of the Aid flow (current US$) in New Zealand in 1997 to that in 2006?
Your response must be concise. 0.01. What is the ratio of the Aid flow (current US$) in Ireland in 1997 to that in 2006?
Your answer should be compact. 0.12. What is the ratio of the Aid flow (current US$) of Spain in 1997 to that in 2006?
Make the answer very short. 0.81. What is the ratio of the Aid flow (current US$) in New Zealand in 1997 to that in 2008?
Provide a succinct answer. 0.02. What is the ratio of the Aid flow (current US$) in Spain in 1997 to that in 2008?
Your answer should be compact. 1.15. What is the ratio of the Aid flow (current US$) in New Zealand in 1997 to that in 2009?
Your answer should be compact. 0.02. What is the ratio of the Aid flow (current US$) in Ireland in 1997 to that in 2009?
Make the answer very short. 0.62. What is the ratio of the Aid flow (current US$) in Spain in 1997 to that in 2009?
Ensure brevity in your answer.  1.2. What is the ratio of the Aid flow (current US$) of New Zealand in 1997 to that in 2010?
Give a very brief answer. 0.02. What is the ratio of the Aid flow (current US$) of Ireland in 1997 to that in 2010?
Offer a terse response. 0.83. What is the ratio of the Aid flow (current US$) in Spain in 1997 to that in 2010?
Your answer should be compact. 0.89. What is the ratio of the Aid flow (current US$) of New Zealand in 1997 to that in 2011?
Ensure brevity in your answer.  0.01. What is the ratio of the Aid flow (current US$) of Ireland in 1997 to that in 2011?
Keep it short and to the point. 0.29. What is the ratio of the Aid flow (current US$) in Spain in 1997 to that in 2011?
Make the answer very short. 0.87. What is the ratio of the Aid flow (current US$) of New Zealand in 1997 to that in 2012?
Make the answer very short. 0.03. What is the ratio of the Aid flow (current US$) of Spain in 1997 to that in 2012?
Offer a very short reply. 0.94. What is the ratio of the Aid flow (current US$) of New Zealand in 2006 to that in 2008?
Make the answer very short. 1.33. What is the ratio of the Aid flow (current US$) in Ireland in 2006 to that in 2008?
Your response must be concise. 5.86. What is the ratio of the Aid flow (current US$) in Spain in 2006 to that in 2008?
Keep it short and to the point. 1.42. What is the ratio of the Aid flow (current US$) in New Zealand in 2006 to that in 2009?
Offer a very short reply. 1.47. What is the ratio of the Aid flow (current US$) of Ireland in 2006 to that in 2009?
Offer a very short reply. 5.12. What is the ratio of the Aid flow (current US$) in Spain in 2006 to that in 2009?
Your answer should be compact. 1.47. What is the ratio of the Aid flow (current US$) in Ireland in 2006 to that in 2010?
Your answer should be compact. 6.83. What is the ratio of the Aid flow (current US$) of New Zealand in 2006 to that in 2011?
Keep it short and to the point. 1.17. What is the ratio of the Aid flow (current US$) in Ireland in 2006 to that in 2011?
Make the answer very short. 2.41. What is the ratio of the Aid flow (current US$) of Spain in 2006 to that in 2011?
Offer a terse response. 1.07. What is the ratio of the Aid flow (current US$) of New Zealand in 2006 to that in 2012?
Make the answer very short. 2.02. What is the ratio of the Aid flow (current US$) in Ireland in 2006 to that in 2012?
Provide a short and direct response. 5.86. What is the ratio of the Aid flow (current US$) of Spain in 2006 to that in 2012?
Offer a terse response. 1.16. What is the ratio of the Aid flow (current US$) of New Zealand in 2008 to that in 2009?
Provide a succinct answer. 1.11. What is the ratio of the Aid flow (current US$) of Spain in 2008 to that in 2009?
Provide a succinct answer. 1.04. What is the ratio of the Aid flow (current US$) of New Zealand in 2008 to that in 2010?
Give a very brief answer. 0.97. What is the ratio of the Aid flow (current US$) of Spain in 2008 to that in 2010?
Make the answer very short. 0.77. What is the ratio of the Aid flow (current US$) in New Zealand in 2008 to that in 2011?
Ensure brevity in your answer.  0.88. What is the ratio of the Aid flow (current US$) in Ireland in 2008 to that in 2011?
Provide a short and direct response. 0.41. What is the ratio of the Aid flow (current US$) of Spain in 2008 to that in 2011?
Your answer should be very brief. 0.75. What is the ratio of the Aid flow (current US$) in New Zealand in 2008 to that in 2012?
Your answer should be compact. 1.52. What is the ratio of the Aid flow (current US$) of Spain in 2008 to that in 2012?
Provide a short and direct response. 0.82. What is the ratio of the Aid flow (current US$) in New Zealand in 2009 to that in 2010?
Keep it short and to the point. 0.87. What is the ratio of the Aid flow (current US$) in Ireland in 2009 to that in 2010?
Keep it short and to the point. 1.33. What is the ratio of the Aid flow (current US$) of Spain in 2009 to that in 2010?
Offer a very short reply. 0.74. What is the ratio of the Aid flow (current US$) of New Zealand in 2009 to that in 2011?
Your answer should be compact. 0.8. What is the ratio of the Aid flow (current US$) of Ireland in 2009 to that in 2011?
Offer a very short reply. 0.47. What is the ratio of the Aid flow (current US$) of Spain in 2009 to that in 2011?
Provide a short and direct response. 0.72. What is the ratio of the Aid flow (current US$) in New Zealand in 2009 to that in 2012?
Provide a succinct answer. 1.38. What is the ratio of the Aid flow (current US$) of Ireland in 2009 to that in 2012?
Offer a terse response. 1.14. What is the ratio of the Aid flow (current US$) in Spain in 2009 to that in 2012?
Give a very brief answer. 0.78. What is the ratio of the Aid flow (current US$) of New Zealand in 2010 to that in 2011?
Give a very brief answer. 0.91. What is the ratio of the Aid flow (current US$) of Ireland in 2010 to that in 2011?
Your answer should be compact. 0.35. What is the ratio of the Aid flow (current US$) of Spain in 2010 to that in 2011?
Provide a short and direct response. 0.98. What is the ratio of the Aid flow (current US$) in New Zealand in 2010 to that in 2012?
Offer a very short reply. 1.57. What is the ratio of the Aid flow (current US$) of Spain in 2010 to that in 2012?
Keep it short and to the point. 1.06. What is the ratio of the Aid flow (current US$) of New Zealand in 2011 to that in 2012?
Give a very brief answer. 1.73. What is the ratio of the Aid flow (current US$) of Ireland in 2011 to that in 2012?
Make the answer very short. 2.43. What is the ratio of the Aid flow (current US$) of Spain in 2011 to that in 2012?
Ensure brevity in your answer.  1.08. What is the difference between the highest and the second highest Aid flow (current US$) in New Zealand?
Keep it short and to the point. 1.20e+05. What is the difference between the highest and the second highest Aid flow (current US$) of Ireland?
Provide a short and direct response. 2.40e+05. What is the difference between the highest and the second highest Aid flow (current US$) of Spain?
Keep it short and to the point. 1.60e+05. What is the difference between the highest and the lowest Aid flow (current US$) in New Zealand?
Your answer should be compact. 8.00e+05. What is the difference between the highest and the lowest Aid flow (current US$) of Ireland?
Ensure brevity in your answer.  3.80e+05. What is the difference between the highest and the lowest Aid flow (current US$) of Spain?
Your response must be concise. 2.50e+06. 